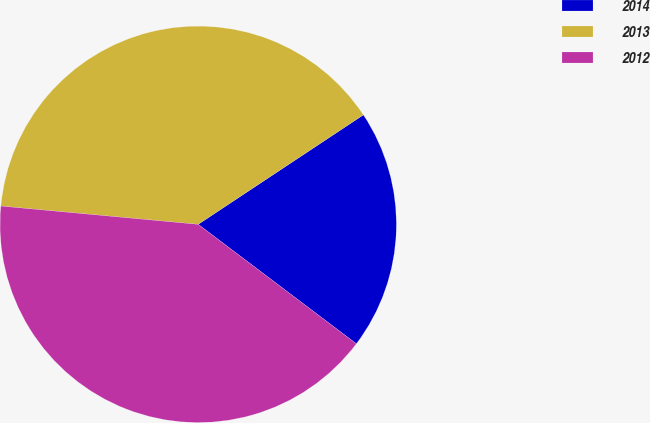Convert chart. <chart><loc_0><loc_0><loc_500><loc_500><pie_chart><fcel>2014<fcel>2013<fcel>2012<nl><fcel>19.61%<fcel>39.22%<fcel>41.18%<nl></chart> 